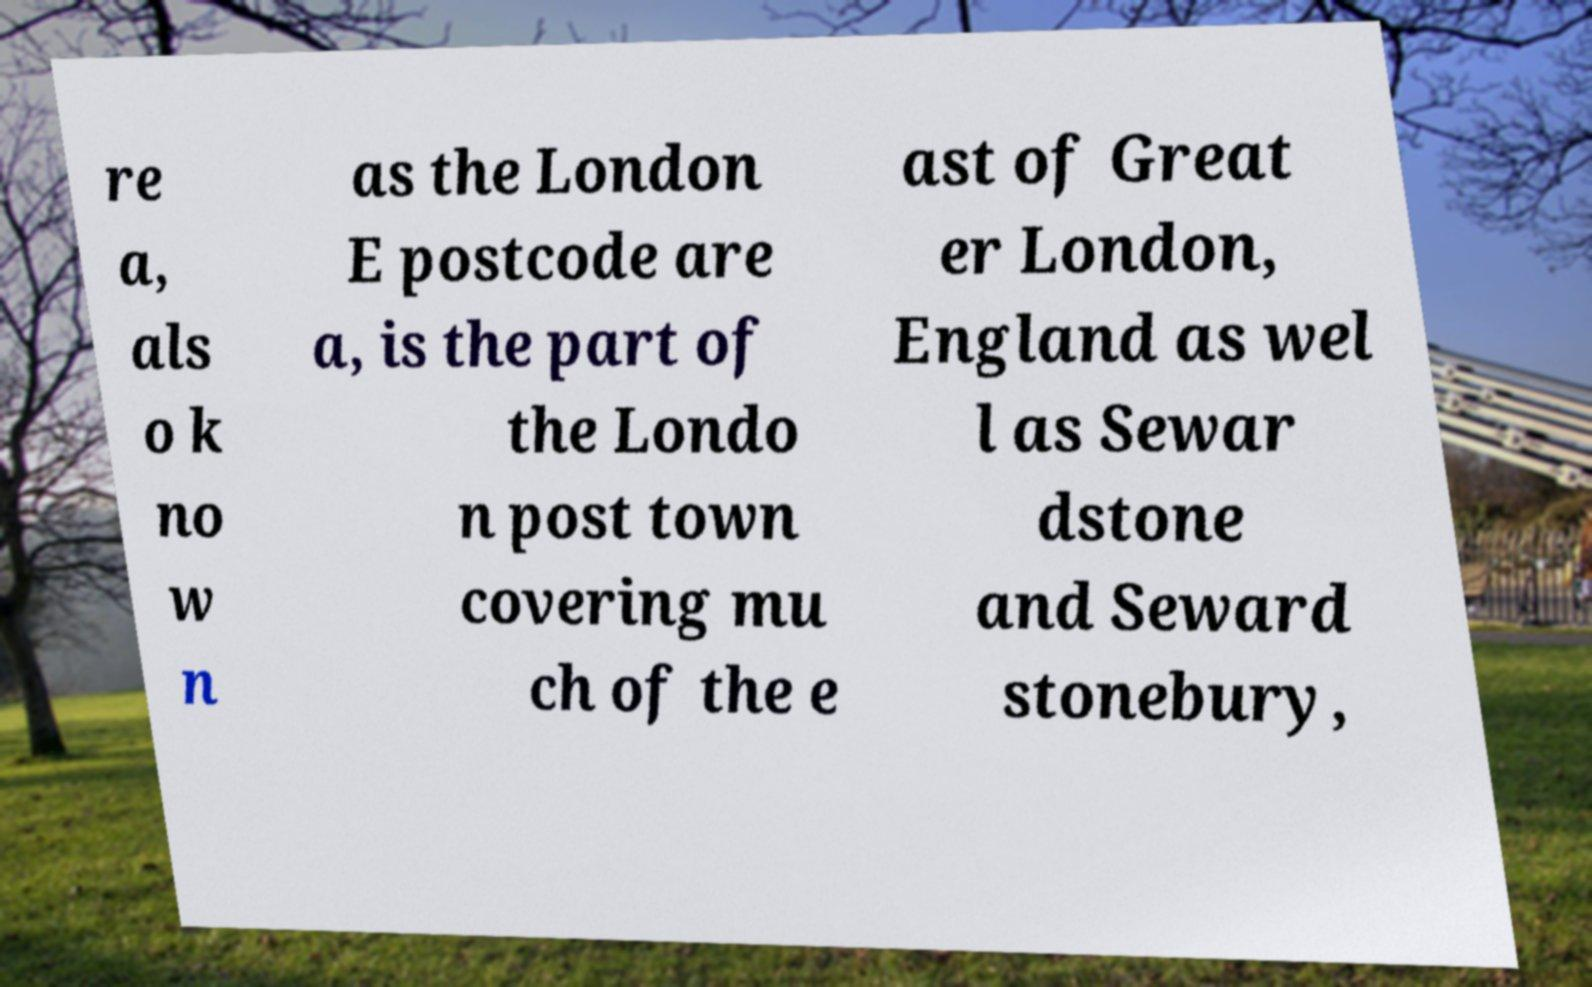Can you accurately transcribe the text from the provided image for me? re a, als o k no w n as the London E postcode are a, is the part of the Londo n post town covering mu ch of the e ast of Great er London, England as wel l as Sewar dstone and Seward stonebury, 